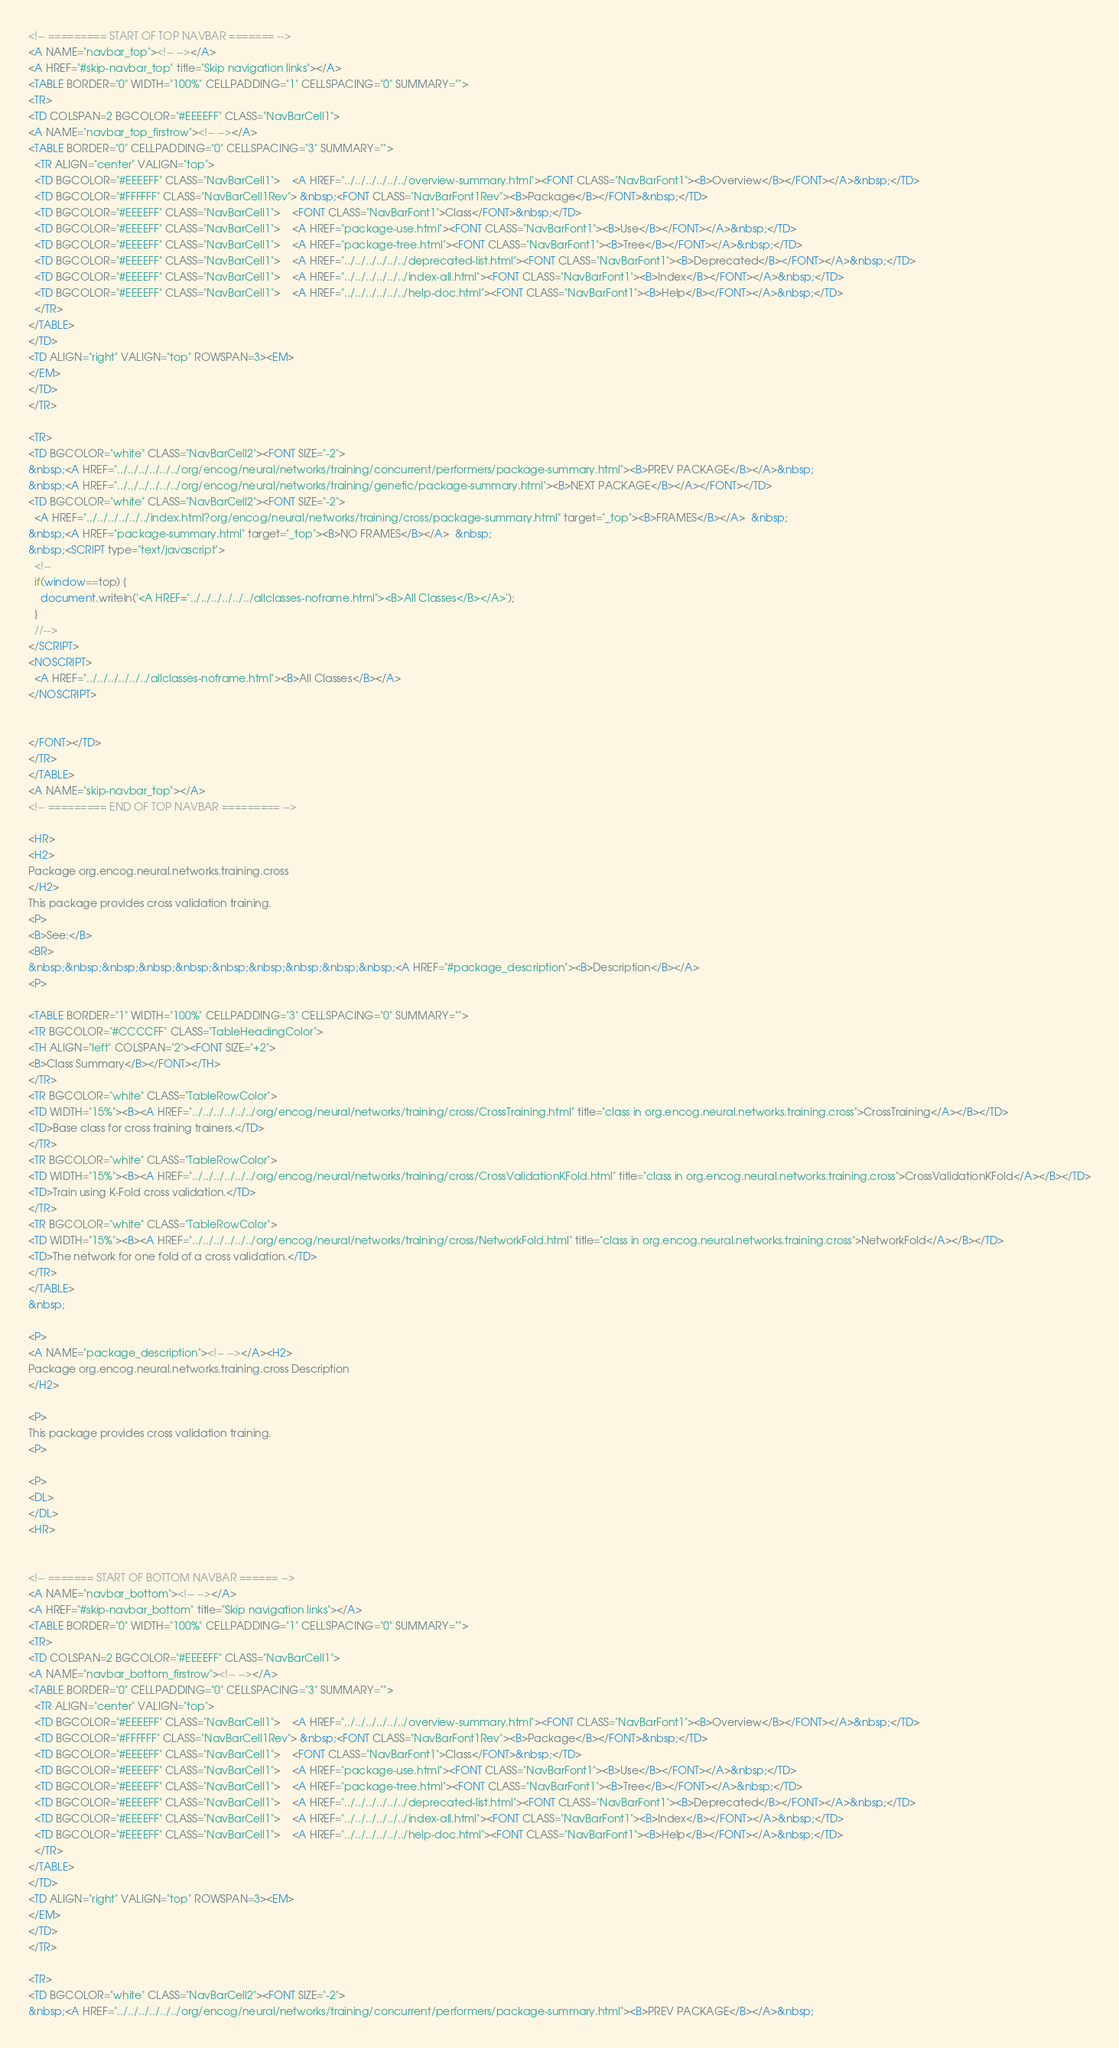Convert code to text. <code><loc_0><loc_0><loc_500><loc_500><_HTML_>
<!-- ========= START OF TOP NAVBAR ======= -->
<A NAME="navbar_top"><!-- --></A>
<A HREF="#skip-navbar_top" title="Skip navigation links"></A>
<TABLE BORDER="0" WIDTH="100%" CELLPADDING="1" CELLSPACING="0" SUMMARY="">
<TR>
<TD COLSPAN=2 BGCOLOR="#EEEEFF" CLASS="NavBarCell1">
<A NAME="navbar_top_firstrow"><!-- --></A>
<TABLE BORDER="0" CELLPADDING="0" CELLSPACING="3" SUMMARY="">
  <TR ALIGN="center" VALIGN="top">
  <TD BGCOLOR="#EEEEFF" CLASS="NavBarCell1">    <A HREF="../../../../../../overview-summary.html"><FONT CLASS="NavBarFont1"><B>Overview</B></FONT></A>&nbsp;</TD>
  <TD BGCOLOR="#FFFFFF" CLASS="NavBarCell1Rev"> &nbsp;<FONT CLASS="NavBarFont1Rev"><B>Package</B></FONT>&nbsp;</TD>
  <TD BGCOLOR="#EEEEFF" CLASS="NavBarCell1">    <FONT CLASS="NavBarFont1">Class</FONT>&nbsp;</TD>
  <TD BGCOLOR="#EEEEFF" CLASS="NavBarCell1">    <A HREF="package-use.html"><FONT CLASS="NavBarFont1"><B>Use</B></FONT></A>&nbsp;</TD>
  <TD BGCOLOR="#EEEEFF" CLASS="NavBarCell1">    <A HREF="package-tree.html"><FONT CLASS="NavBarFont1"><B>Tree</B></FONT></A>&nbsp;</TD>
  <TD BGCOLOR="#EEEEFF" CLASS="NavBarCell1">    <A HREF="../../../../../../deprecated-list.html"><FONT CLASS="NavBarFont1"><B>Deprecated</B></FONT></A>&nbsp;</TD>
  <TD BGCOLOR="#EEEEFF" CLASS="NavBarCell1">    <A HREF="../../../../../../index-all.html"><FONT CLASS="NavBarFont1"><B>Index</B></FONT></A>&nbsp;</TD>
  <TD BGCOLOR="#EEEEFF" CLASS="NavBarCell1">    <A HREF="../../../../../../help-doc.html"><FONT CLASS="NavBarFont1"><B>Help</B></FONT></A>&nbsp;</TD>
  </TR>
</TABLE>
</TD>
<TD ALIGN="right" VALIGN="top" ROWSPAN=3><EM>
</EM>
</TD>
</TR>

<TR>
<TD BGCOLOR="white" CLASS="NavBarCell2"><FONT SIZE="-2">
&nbsp;<A HREF="../../../../../../org/encog/neural/networks/training/concurrent/performers/package-summary.html"><B>PREV PACKAGE</B></A>&nbsp;
&nbsp;<A HREF="../../../../../../org/encog/neural/networks/training/genetic/package-summary.html"><B>NEXT PACKAGE</B></A></FONT></TD>
<TD BGCOLOR="white" CLASS="NavBarCell2"><FONT SIZE="-2">
  <A HREF="../../../../../../index.html?org/encog/neural/networks/training/cross/package-summary.html" target="_top"><B>FRAMES</B></A>  &nbsp;
&nbsp;<A HREF="package-summary.html" target="_top"><B>NO FRAMES</B></A>  &nbsp;
&nbsp;<SCRIPT type="text/javascript">
  <!--
  if(window==top) {
    document.writeln('<A HREF="../../../../../../allclasses-noframe.html"><B>All Classes</B></A>');
  }
  //-->
</SCRIPT>
<NOSCRIPT>
  <A HREF="../../../../../../allclasses-noframe.html"><B>All Classes</B></A>
</NOSCRIPT>


</FONT></TD>
</TR>
</TABLE>
<A NAME="skip-navbar_top"></A>
<!-- ========= END OF TOP NAVBAR ========= -->

<HR>
<H2>
Package org.encog.neural.networks.training.cross
</H2>
This package provides cross validation training.
<P>
<B>See:</B>
<BR>
&nbsp;&nbsp;&nbsp;&nbsp;&nbsp;&nbsp;&nbsp;&nbsp;&nbsp;&nbsp;<A HREF="#package_description"><B>Description</B></A>
<P>

<TABLE BORDER="1" WIDTH="100%" CELLPADDING="3" CELLSPACING="0" SUMMARY="">
<TR BGCOLOR="#CCCCFF" CLASS="TableHeadingColor">
<TH ALIGN="left" COLSPAN="2"><FONT SIZE="+2">
<B>Class Summary</B></FONT></TH>
</TR>
<TR BGCOLOR="white" CLASS="TableRowColor">
<TD WIDTH="15%"><B><A HREF="../../../../../../org/encog/neural/networks/training/cross/CrossTraining.html" title="class in org.encog.neural.networks.training.cross">CrossTraining</A></B></TD>
<TD>Base class for cross training trainers.</TD>
</TR>
<TR BGCOLOR="white" CLASS="TableRowColor">
<TD WIDTH="15%"><B><A HREF="../../../../../../org/encog/neural/networks/training/cross/CrossValidationKFold.html" title="class in org.encog.neural.networks.training.cross">CrossValidationKFold</A></B></TD>
<TD>Train using K-Fold cross validation.</TD>
</TR>
<TR BGCOLOR="white" CLASS="TableRowColor">
<TD WIDTH="15%"><B><A HREF="../../../../../../org/encog/neural/networks/training/cross/NetworkFold.html" title="class in org.encog.neural.networks.training.cross">NetworkFold</A></B></TD>
<TD>The network for one fold of a cross validation.</TD>
</TR>
</TABLE>
&nbsp;

<P>
<A NAME="package_description"><!-- --></A><H2>
Package org.encog.neural.networks.training.cross Description
</H2>

<P>
This package provides cross validation training.
<P>

<P>
<DL>
</DL>
<HR>


<!-- ======= START OF BOTTOM NAVBAR ====== -->
<A NAME="navbar_bottom"><!-- --></A>
<A HREF="#skip-navbar_bottom" title="Skip navigation links"></A>
<TABLE BORDER="0" WIDTH="100%" CELLPADDING="1" CELLSPACING="0" SUMMARY="">
<TR>
<TD COLSPAN=2 BGCOLOR="#EEEEFF" CLASS="NavBarCell1">
<A NAME="navbar_bottom_firstrow"><!-- --></A>
<TABLE BORDER="0" CELLPADDING="0" CELLSPACING="3" SUMMARY="">
  <TR ALIGN="center" VALIGN="top">
  <TD BGCOLOR="#EEEEFF" CLASS="NavBarCell1">    <A HREF="../../../../../../overview-summary.html"><FONT CLASS="NavBarFont1"><B>Overview</B></FONT></A>&nbsp;</TD>
  <TD BGCOLOR="#FFFFFF" CLASS="NavBarCell1Rev"> &nbsp;<FONT CLASS="NavBarFont1Rev"><B>Package</B></FONT>&nbsp;</TD>
  <TD BGCOLOR="#EEEEFF" CLASS="NavBarCell1">    <FONT CLASS="NavBarFont1">Class</FONT>&nbsp;</TD>
  <TD BGCOLOR="#EEEEFF" CLASS="NavBarCell1">    <A HREF="package-use.html"><FONT CLASS="NavBarFont1"><B>Use</B></FONT></A>&nbsp;</TD>
  <TD BGCOLOR="#EEEEFF" CLASS="NavBarCell1">    <A HREF="package-tree.html"><FONT CLASS="NavBarFont1"><B>Tree</B></FONT></A>&nbsp;</TD>
  <TD BGCOLOR="#EEEEFF" CLASS="NavBarCell1">    <A HREF="../../../../../../deprecated-list.html"><FONT CLASS="NavBarFont1"><B>Deprecated</B></FONT></A>&nbsp;</TD>
  <TD BGCOLOR="#EEEEFF" CLASS="NavBarCell1">    <A HREF="../../../../../../index-all.html"><FONT CLASS="NavBarFont1"><B>Index</B></FONT></A>&nbsp;</TD>
  <TD BGCOLOR="#EEEEFF" CLASS="NavBarCell1">    <A HREF="../../../../../../help-doc.html"><FONT CLASS="NavBarFont1"><B>Help</B></FONT></A>&nbsp;</TD>
  </TR>
</TABLE>
</TD>
<TD ALIGN="right" VALIGN="top" ROWSPAN=3><EM>
</EM>
</TD>
</TR>

<TR>
<TD BGCOLOR="white" CLASS="NavBarCell2"><FONT SIZE="-2">
&nbsp;<A HREF="../../../../../../org/encog/neural/networks/training/concurrent/performers/package-summary.html"><B>PREV PACKAGE</B></A>&nbsp;</code> 